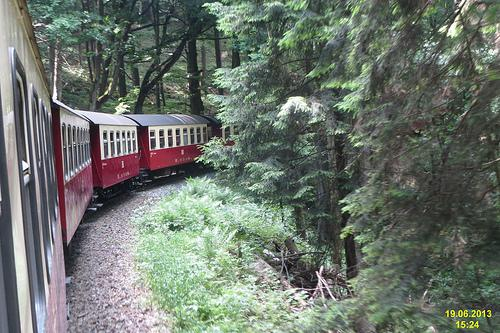Question: what is red?
Choices:
A. Train.
B. Bus.
C. Car.
D. Airplane.
Answer with the letter. Answer: A Question: where are windows?
Choices:
A. In the kitchen.
B. On a train.
C. On the classroom wall.
D. On the van.
Answer with the letter. Answer: B Question: how many trains are there?
Choices:
A. 2.
B. 1.
C. 3.
D. 6.
Answer with the letter. Answer: B Question: where is a train?
Choices:
A. In the depot.
B. On train tracks.
C. At the train stop.
D. Underground.
Answer with the letter. Answer: B Question: where was the photo taken?
Choices:
A. On a train track.
B. From the train.
C. From the platform.
D. From the left of the train tracks.
Answer with the letter. Answer: A 